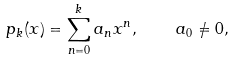<formula> <loc_0><loc_0><loc_500><loc_500>p _ { k } ( x ) = \sum _ { n = 0 } ^ { k } a _ { n } x ^ { n } , \quad a _ { 0 } \neq 0 ,</formula> 